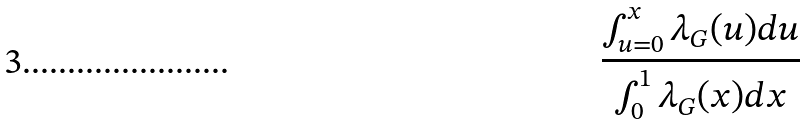<formula> <loc_0><loc_0><loc_500><loc_500>\frac { \int ^ { x } _ { u = 0 } \lambda _ { G } ( u ) d u } { \int ^ { 1 } _ { 0 } \lambda _ { G } ( x ) d x }</formula> 